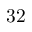<formula> <loc_0><loc_0><loc_500><loc_500>3 2</formula> 